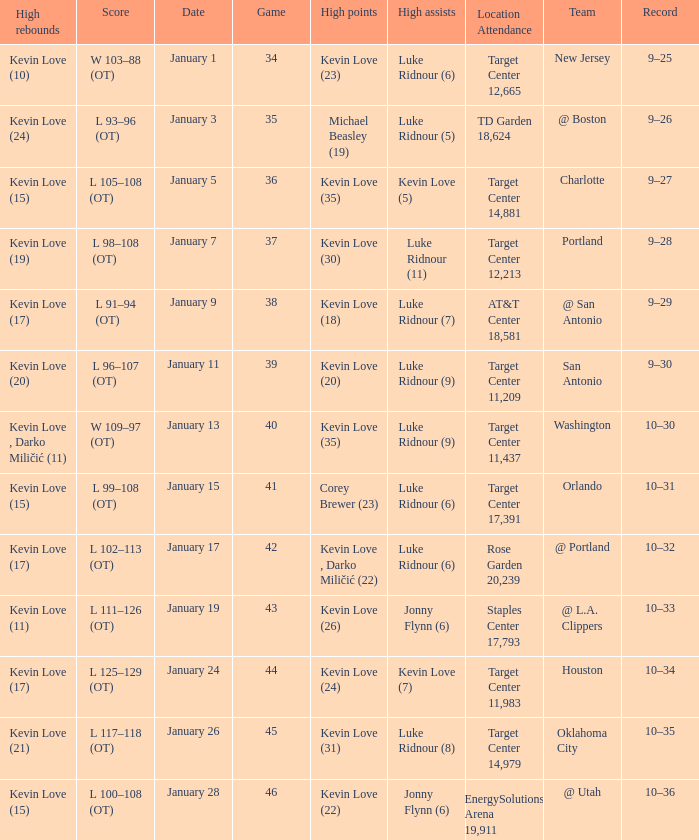What is the highest game with team @ l.a. clippers? 43.0. 